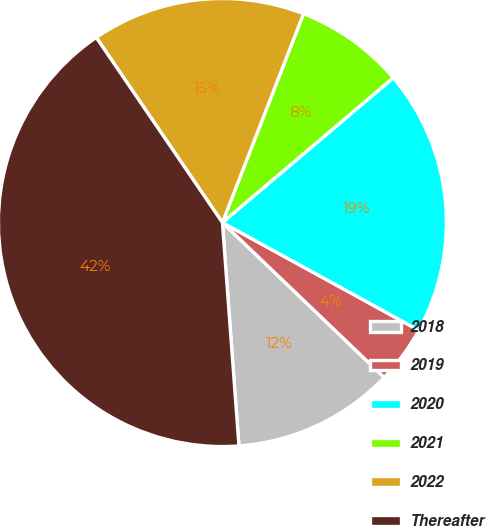Convert chart to OTSL. <chart><loc_0><loc_0><loc_500><loc_500><pie_chart><fcel>2018<fcel>2019<fcel>2020<fcel>2021<fcel>2022<fcel>Thereafter<nl><fcel>11.67%<fcel>4.17%<fcel>19.17%<fcel>7.92%<fcel>15.42%<fcel>41.66%<nl></chart> 